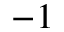Convert formula to latex. <formula><loc_0><loc_0><loc_500><loc_500>^ { - 1 }</formula> 